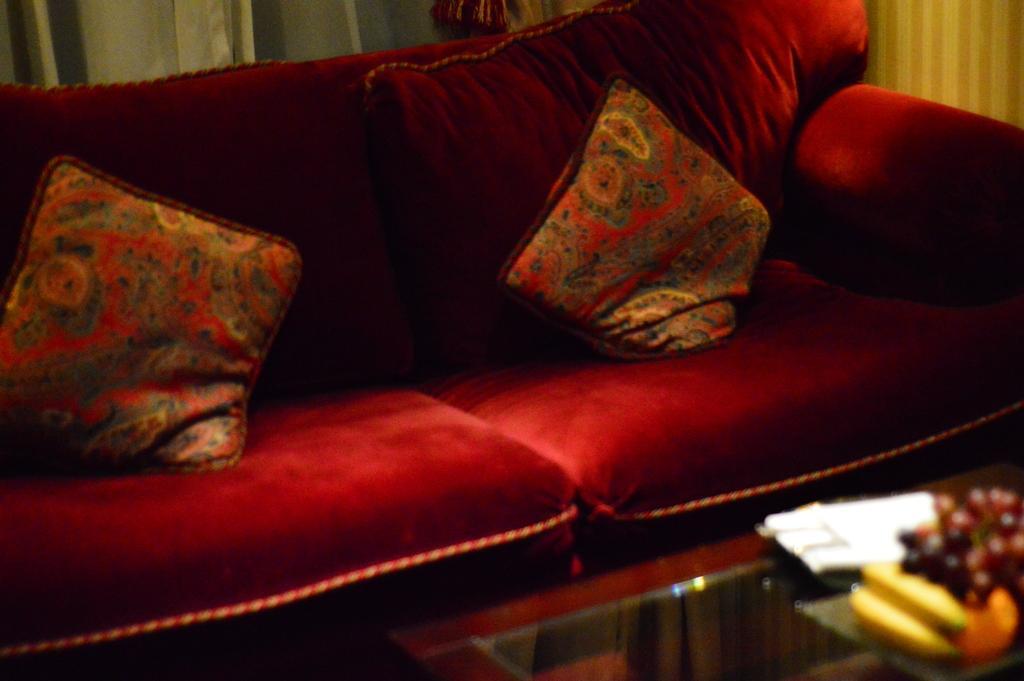Describe this image in one or two sentences. This is a red couch with two cushions on it. This is a table with fruits and a white color object on it. 